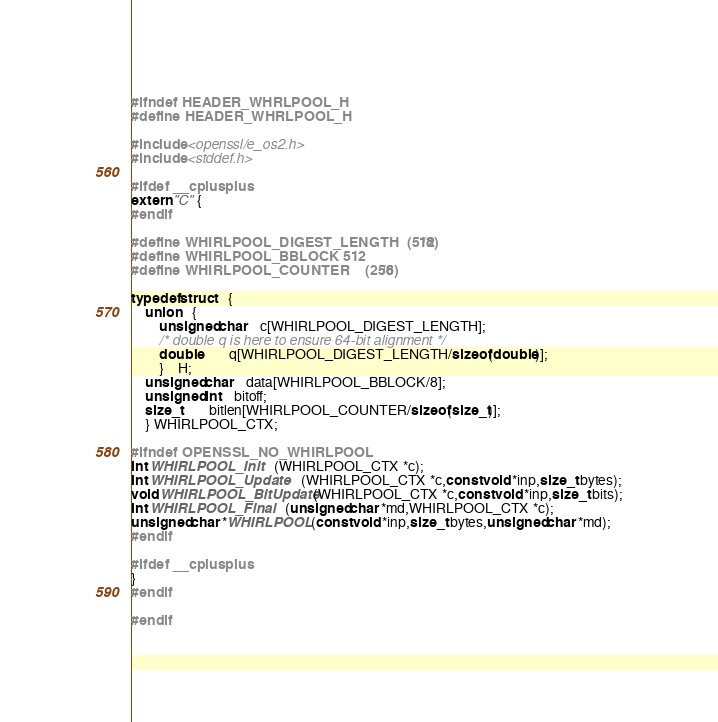Convert code to text. <code><loc_0><loc_0><loc_500><loc_500><_C_>#ifndef HEADER_WHRLPOOL_H
#define HEADER_WHRLPOOL_H

#include <openssl/e_os2.h>
#include <stddef.h>

#ifdef __cplusplus
extern "C" {
#endif

#define WHIRLPOOL_DIGEST_LENGTH	(512/8)
#define WHIRLPOOL_BBLOCK	512
#define WHIRLPOOL_COUNTER	(256/8)

typedef struct	{
	union	{
		unsigned char	c[WHIRLPOOL_DIGEST_LENGTH];
		/* double q is here to ensure 64-bit alignment */
		double		q[WHIRLPOOL_DIGEST_LENGTH/sizeof(double)];
		}	H;
	unsigned char	data[WHIRLPOOL_BBLOCK/8];
	unsigned int	bitoff;
	size_t		bitlen[WHIRLPOOL_COUNTER/sizeof(size_t)];
	} WHIRLPOOL_CTX;

#ifndef OPENSSL_NO_WHIRLPOOL
int WHIRLPOOL_Init	(WHIRLPOOL_CTX *c);
int WHIRLPOOL_Update	(WHIRLPOOL_CTX *c,const void *inp,size_t bytes);
void WHIRLPOOL_BitUpdate(WHIRLPOOL_CTX *c,const void *inp,size_t bits);
int WHIRLPOOL_Final	(unsigned char *md,WHIRLPOOL_CTX *c);
unsigned char *WHIRLPOOL(const void *inp,size_t bytes,unsigned char *md);
#endif

#ifdef __cplusplus
}
#endif

#endif
</code> 